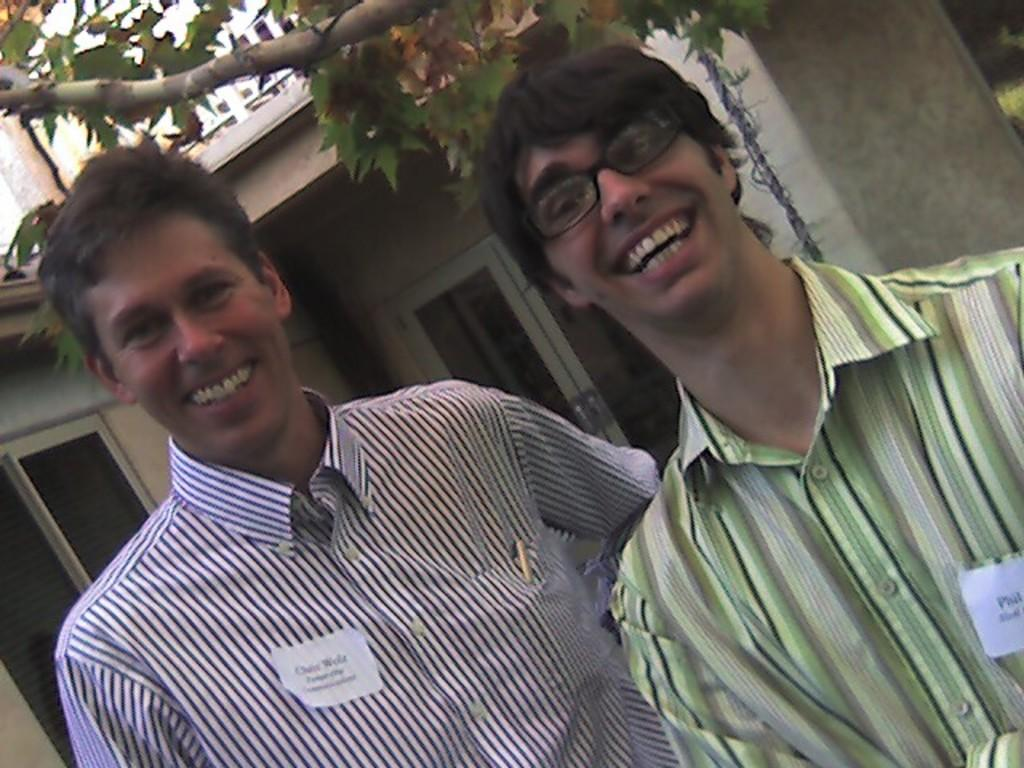How many people are in the image? There are two people standing near a pillar in the image. What can be seen on the shirts of the two persons? Name cards are attached to the shirts of the two persons. What type of vegetation is present in the image? There is a tree in the image. What architectural feature can be seen in the image? There is a pole in the image. What is visible in the background of the image? There is a building with windows visible in the background. How many flocks of birds are flying over the building in the image? There are no flocks of birds visible in the image; only a building with windows is present in the background. What does the mom of one of the persons in the image look like? There is no information about the moms of the persons in the image, as the focus is on the two people standing near the pillar. --- Facts: 1. There is a person holding a book. 2. The book has a blue cover. 3. The person is sitting on a chair. 4. There is a table in the image. 5. The table has a lamp on it. Absurd Topics: unicorn, parrot, magic wand Conversation: What is the person holding in the image? The person is holding a book with a blue cover. What is the person's position in the image? The person is sitting on a chair. What is present on the table in the image? The table has a table lamp on it. Reasoning: Let's think step by step in order to produce the conversation. We start by identifying the main subject of the image, which is the person holding a book. Next, we describe the book's specific features, such as the blue cover. Then, we observe the person's position, noting that they are sitting on a chair. Finally, we describe the objects present on the table, which include a table lamp. Absurd Question/Answer: What type of unicorn can be seen playing with the magic wand in the image? There is no unicorn present in the image. --- Facts: 1. There is a person holding a book. 2. The book has a blue cover. 3. The person is sitting on a chair. 4. There is a table in the image. 5. The table has a table lamp on it. Absurd Topics: unicorn, parrot, magic wand Conversation: What is the person holding in the image? The person is holding a book with a blue cover. What is the person's position in the image? The person is sitting on a chair. What is present on the table in the image? The table has a table lamp on it. Reasoning 